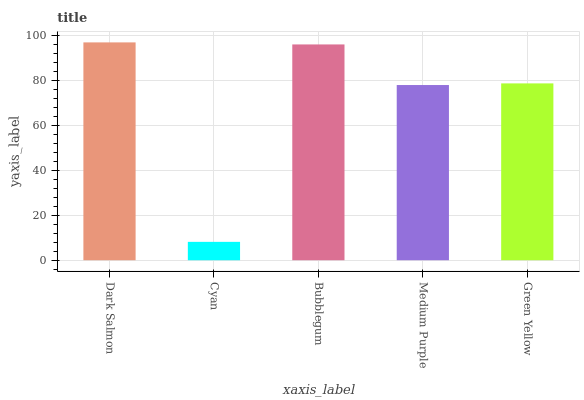Is Cyan the minimum?
Answer yes or no. Yes. Is Dark Salmon the maximum?
Answer yes or no. Yes. Is Bubblegum the minimum?
Answer yes or no. No. Is Bubblegum the maximum?
Answer yes or no. No. Is Bubblegum greater than Cyan?
Answer yes or no. Yes. Is Cyan less than Bubblegum?
Answer yes or no. Yes. Is Cyan greater than Bubblegum?
Answer yes or no. No. Is Bubblegum less than Cyan?
Answer yes or no. No. Is Green Yellow the high median?
Answer yes or no. Yes. Is Green Yellow the low median?
Answer yes or no. Yes. Is Cyan the high median?
Answer yes or no. No. Is Dark Salmon the low median?
Answer yes or no. No. 